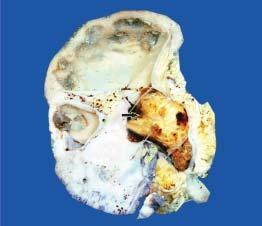what does the pelvis of the kidney contain?
Answer the question using a single word or phrase. A single 